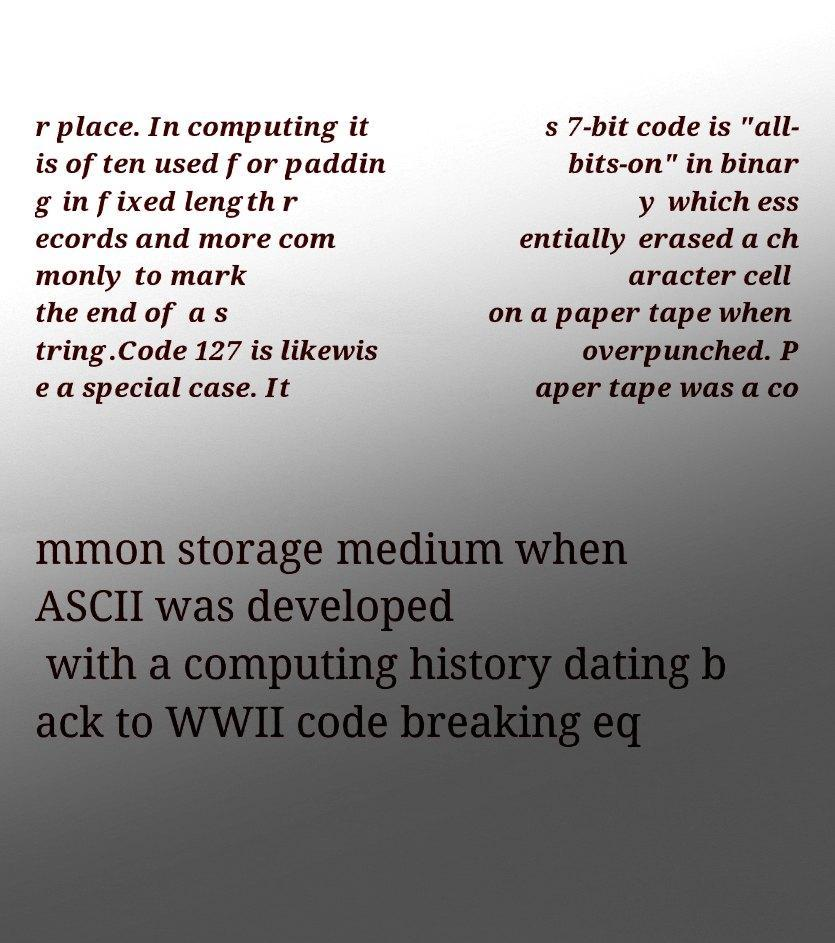What messages or text are displayed in this image? I need them in a readable, typed format. r place. In computing it is often used for paddin g in fixed length r ecords and more com monly to mark the end of a s tring.Code 127 is likewis e a special case. It s 7-bit code is "all- bits-on" in binar y which ess entially erased a ch aracter cell on a paper tape when overpunched. P aper tape was a co mmon storage medium when ASCII was developed with a computing history dating b ack to WWII code breaking eq 